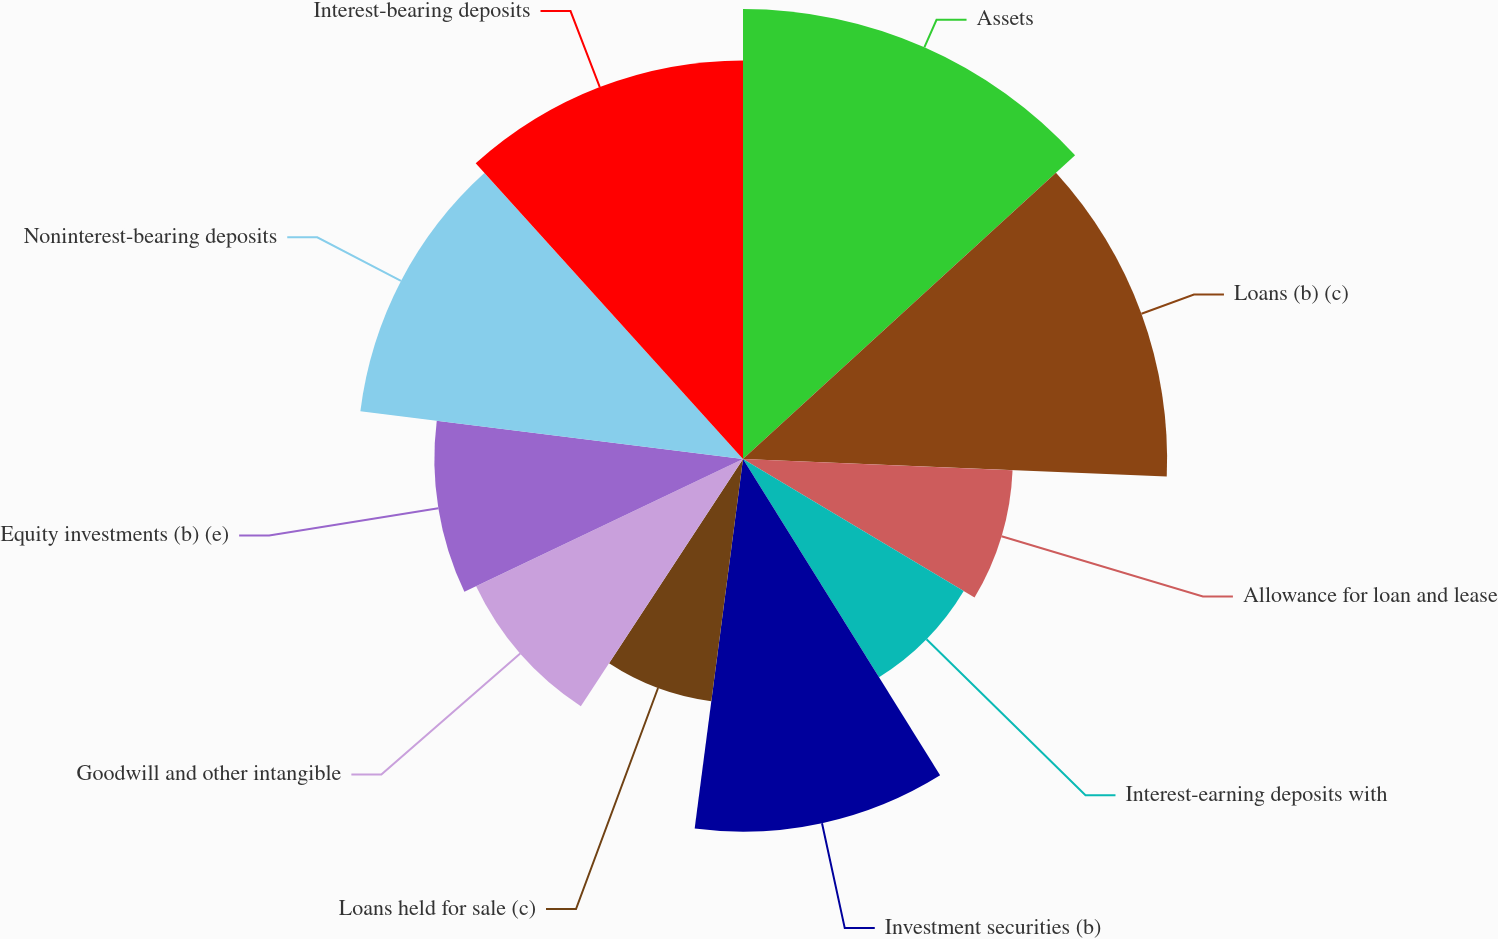<chart> <loc_0><loc_0><loc_500><loc_500><pie_chart><fcel>Assets<fcel>Loans (b) (c)<fcel>Allowance for loan and lease<fcel>Interest-earning deposits with<fcel>Investment securities (b)<fcel>Loans held for sale (c)<fcel>Goodwill and other intangible<fcel>Equity investments (b) (e)<fcel>Noninterest-bearing deposits<fcel>Interest-bearing deposits<nl><fcel>13.21%<fcel>12.45%<fcel>7.92%<fcel>7.55%<fcel>10.94%<fcel>7.17%<fcel>8.68%<fcel>9.06%<fcel>11.32%<fcel>11.7%<nl></chart> 